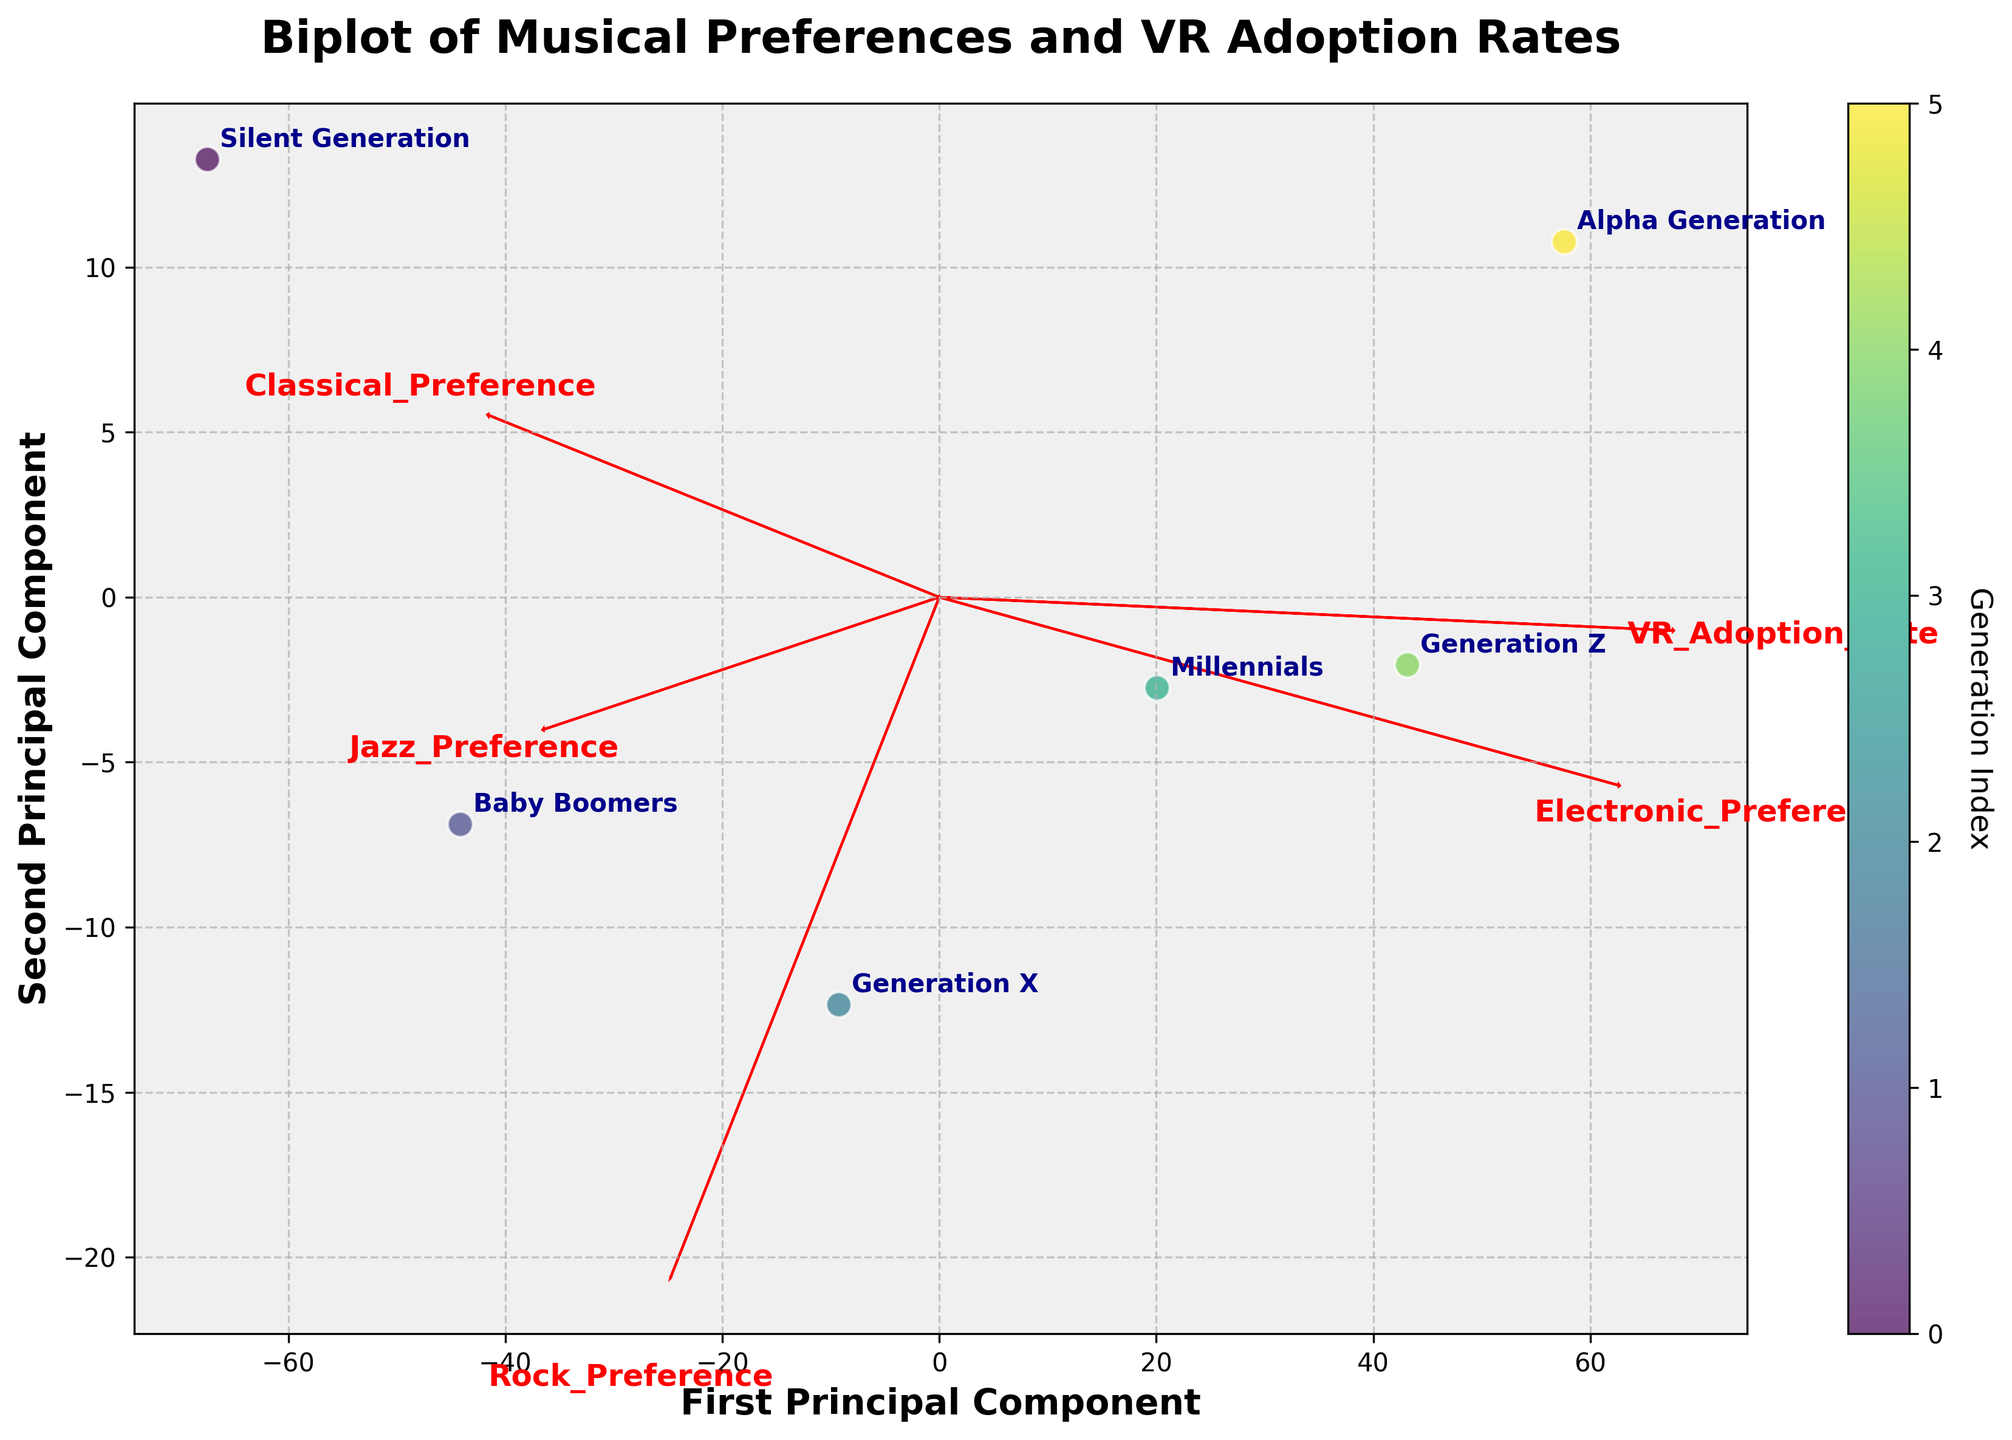How many generations are represented in the plot? Count the number of labeled points on the plot. Each point corresponds to a generation.
Answer: 6 Which generation shows the highest VR adoption rate? Look at the plotted data points and identify which one corresponds to the highest VR adoption rate. The generation with the highest rate will be furthest along the VR_Adoption_Rate axis.
Answer: Alpha Generation What is the second principal component axis labeled as? Read the label of the second axis from the biplot. It is usually stated "Second Principal Component" on the axis.
Answer: Second Principal Component How does the Rock Preference vector direction compare to the Classical Preference vector? Observe the directions of the vectors representing Rock and Classical preferences. Determine if they point in similar or opposite directions.
Answer: Opposite directions Which two generations have the most similar positions in the biplot? Find the data points that are closest to each other based on their positions in the biplot. Check the annotated labels for these points.
Answer: Millennials and Generation Z Which preference vectors are pointing in approximately the same direction? Examine the vectors and note which ones are aligned or nearly parallel to each other.
Answer: Jazz Preference and Classical Preference What preference trends can be observed in generations with high VR adoption rates? Notice the positions of the generations with high VR adoption (Millennials, Generation Z, Alpha Generation) and the directions of preference vectors they are close to.
Answer: High Electronic Preference, low Rock Preference How does the preference for Jazz change across generations? Observe the position of generations along the Jazz Preference vector. Check if the positions move upward or downward as the generations become younger.
Answer: Decreases Which generation is positioned farthest from the origin in the biplot? Identify the point that is the most distant from the center (0,0) based on the plotted data.
Answer: Alpha Generation Is there a trend between VR adoption and Rock Preference when moving from the older to younger generations? Look at the positions of data points representing the generations and observe their VR adoption and Rock Preference coordinates. See if there’s an increasing or decreasing trend.
Answer: Decreases 